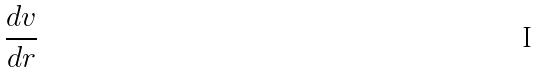Convert formula to latex. <formula><loc_0><loc_0><loc_500><loc_500>\frac { d v } { d r }</formula> 